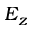<formula> <loc_0><loc_0><loc_500><loc_500>E _ { z }</formula> 